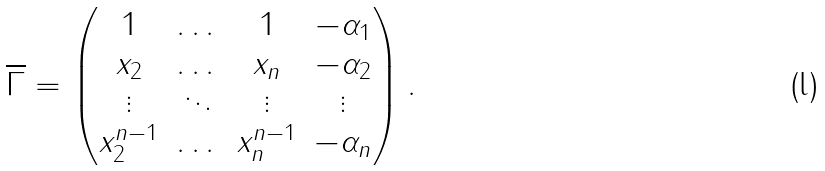<formula> <loc_0><loc_0><loc_500><loc_500>\overline { \Gamma } = \begin{pmatrix} 1 & \dots & 1 & - \alpha _ { 1 } \\ x _ { 2 } & \dots & x _ { n } & - \alpha _ { 2 } \\ \vdots & \ddots & \vdots & \vdots \\ x _ { 2 } ^ { n - 1 } & \dots & x _ { n } ^ { n - 1 } & - \alpha _ { n } \end{pmatrix} .</formula> 